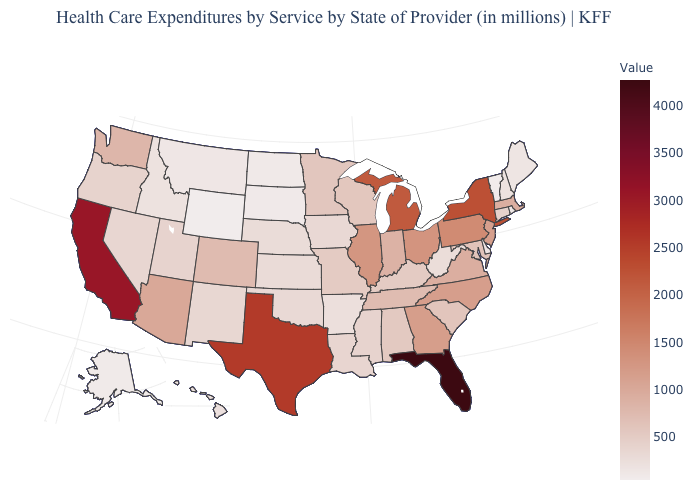Is the legend a continuous bar?
Give a very brief answer. Yes. Among the states that border Utah , which have the lowest value?
Quick response, please. Wyoming. Which states have the lowest value in the MidWest?
Be succinct. South Dakota. Which states have the highest value in the USA?
Concise answer only. Florida. 